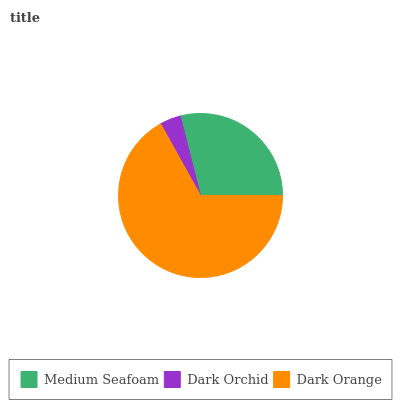Is Dark Orchid the minimum?
Answer yes or no. Yes. Is Dark Orange the maximum?
Answer yes or no. Yes. Is Dark Orange the minimum?
Answer yes or no. No. Is Dark Orchid the maximum?
Answer yes or no. No. Is Dark Orange greater than Dark Orchid?
Answer yes or no. Yes. Is Dark Orchid less than Dark Orange?
Answer yes or no. Yes. Is Dark Orchid greater than Dark Orange?
Answer yes or no. No. Is Dark Orange less than Dark Orchid?
Answer yes or no. No. Is Medium Seafoam the high median?
Answer yes or no. Yes. Is Medium Seafoam the low median?
Answer yes or no. Yes. Is Dark Orchid the high median?
Answer yes or no. No. Is Dark Orchid the low median?
Answer yes or no. No. 